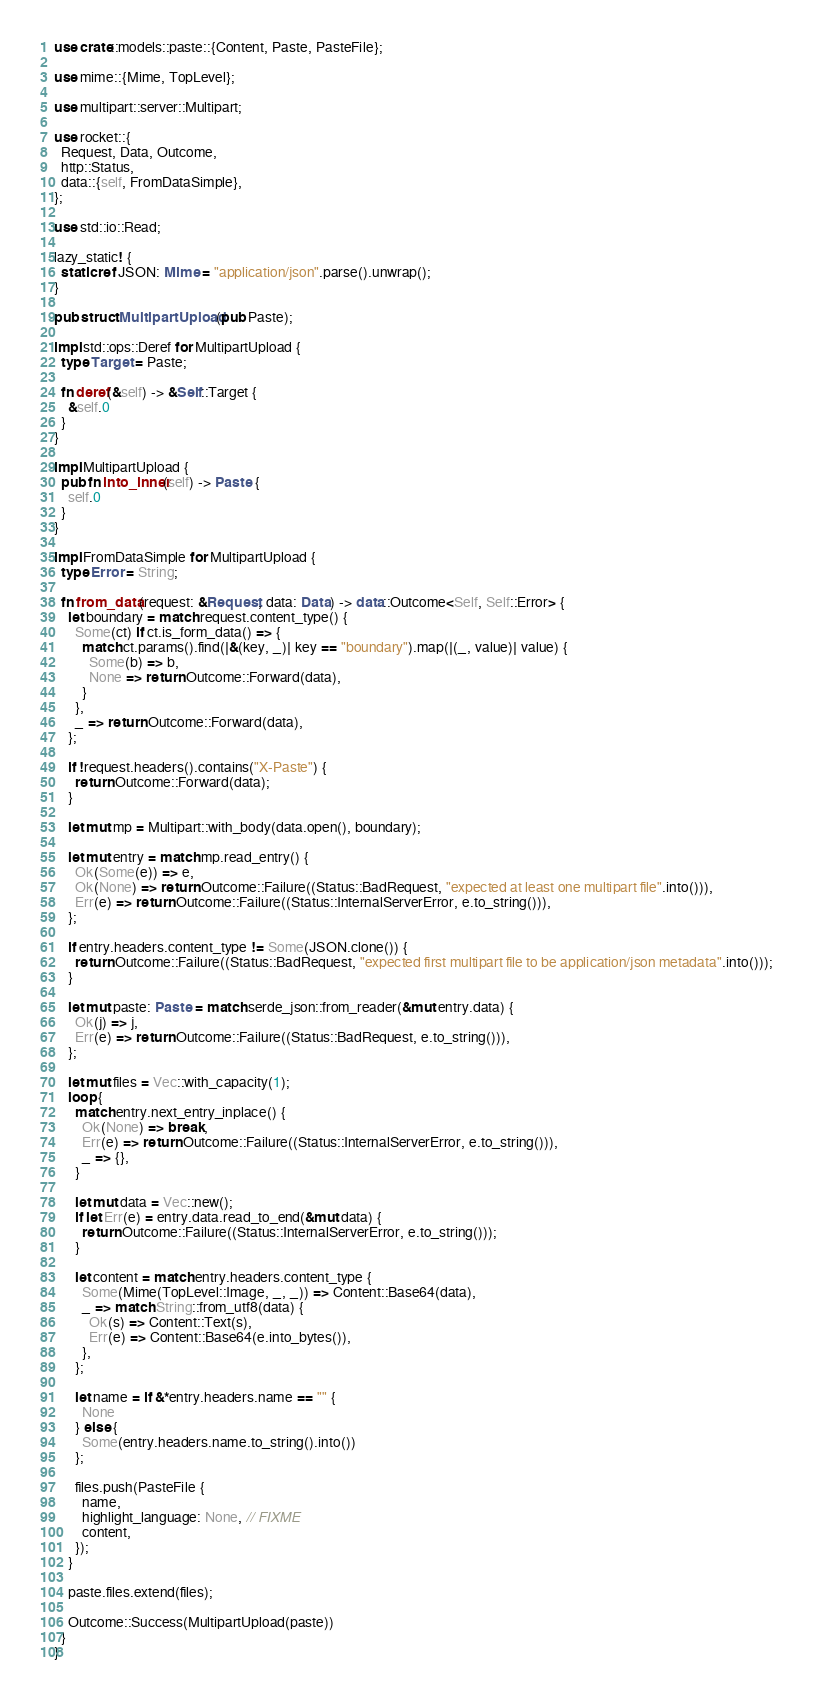Convert code to text. <code><loc_0><loc_0><loc_500><loc_500><_Rust_>use crate::models::paste::{Content, Paste, PasteFile};

use mime::{Mime, TopLevel};

use multipart::server::Multipart;

use rocket::{
  Request, Data, Outcome,
  http::Status,
  data::{self, FromDataSimple},
};

use std::io::Read;

lazy_static! {
  static ref JSON: Mime = "application/json".parse().unwrap();
}

pub struct MultipartUpload(pub Paste);

impl std::ops::Deref for MultipartUpload {
  type Target = Paste;

  fn deref(&self) -> &Self::Target {
    &self.0
  }
}

impl MultipartUpload {
  pub fn into_inner(self) -> Paste {
    self.0
  }
}

impl FromDataSimple for MultipartUpload {
  type Error = String;

  fn from_data(request: &Request, data: Data) -> data::Outcome<Self, Self::Error> {
    let boundary = match request.content_type() {
      Some(ct) if ct.is_form_data() => {
        match ct.params().find(|&(key, _)| key == "boundary").map(|(_, value)| value) {
          Some(b) => b,
          None => return Outcome::Forward(data),
        }
      },
      _ => return Outcome::Forward(data),
    };

    if !request.headers().contains("X-Paste") {
      return Outcome::Forward(data);
    }

    let mut mp = Multipart::with_body(data.open(), boundary);

    let mut entry = match mp.read_entry() {
      Ok(Some(e)) => e,
      Ok(None) => return Outcome::Failure((Status::BadRequest, "expected at least one multipart file".into())),
      Err(e) => return Outcome::Failure((Status::InternalServerError, e.to_string())),
    };

    if entry.headers.content_type != Some(JSON.clone()) {
      return Outcome::Failure((Status::BadRequest, "expected first multipart file to be application/json metadata".into()));
    }

    let mut paste: Paste = match serde_json::from_reader(&mut entry.data) {
      Ok(j) => j,
      Err(e) => return Outcome::Failure((Status::BadRequest, e.to_string())),
    };

    let mut files = Vec::with_capacity(1);
    loop {
      match entry.next_entry_inplace() {
        Ok(None) => break,
        Err(e) => return Outcome::Failure((Status::InternalServerError, e.to_string())),
        _ => {},
      }

      let mut data = Vec::new();
      if let Err(e) = entry.data.read_to_end(&mut data) {
        return Outcome::Failure((Status::InternalServerError, e.to_string()));
      }

      let content = match entry.headers.content_type {
        Some(Mime(TopLevel::Image, _, _)) => Content::Base64(data),
        _ => match String::from_utf8(data) {
          Ok(s) => Content::Text(s),
          Err(e) => Content::Base64(e.into_bytes()),
        },
      };

      let name = if &*entry.headers.name == "" {
        None
      } else {
        Some(entry.headers.name.to_string().into())
      };

      files.push(PasteFile {
        name,
        highlight_language: None, // FIXME
        content,
      });
    }

    paste.files.extend(files);

    Outcome::Success(MultipartUpload(paste))
  }
}
</code> 